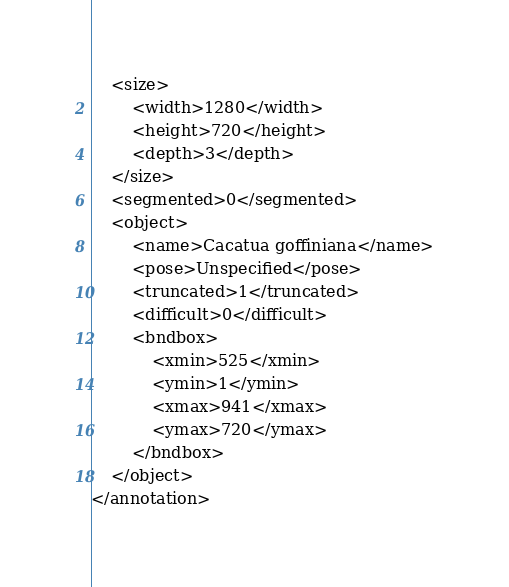<code> <loc_0><loc_0><loc_500><loc_500><_XML_>	<size>
		<width>1280</width>
		<height>720</height>
		<depth>3</depth>
	</size>
	<segmented>0</segmented>
	<object>
		<name>Cacatua goffiniana</name>
		<pose>Unspecified</pose>
		<truncated>1</truncated>
		<difficult>0</difficult>
		<bndbox>
			<xmin>525</xmin>
			<ymin>1</ymin>
			<xmax>941</xmax>
			<ymax>720</ymax>
		</bndbox>
	</object>
</annotation>
</code> 